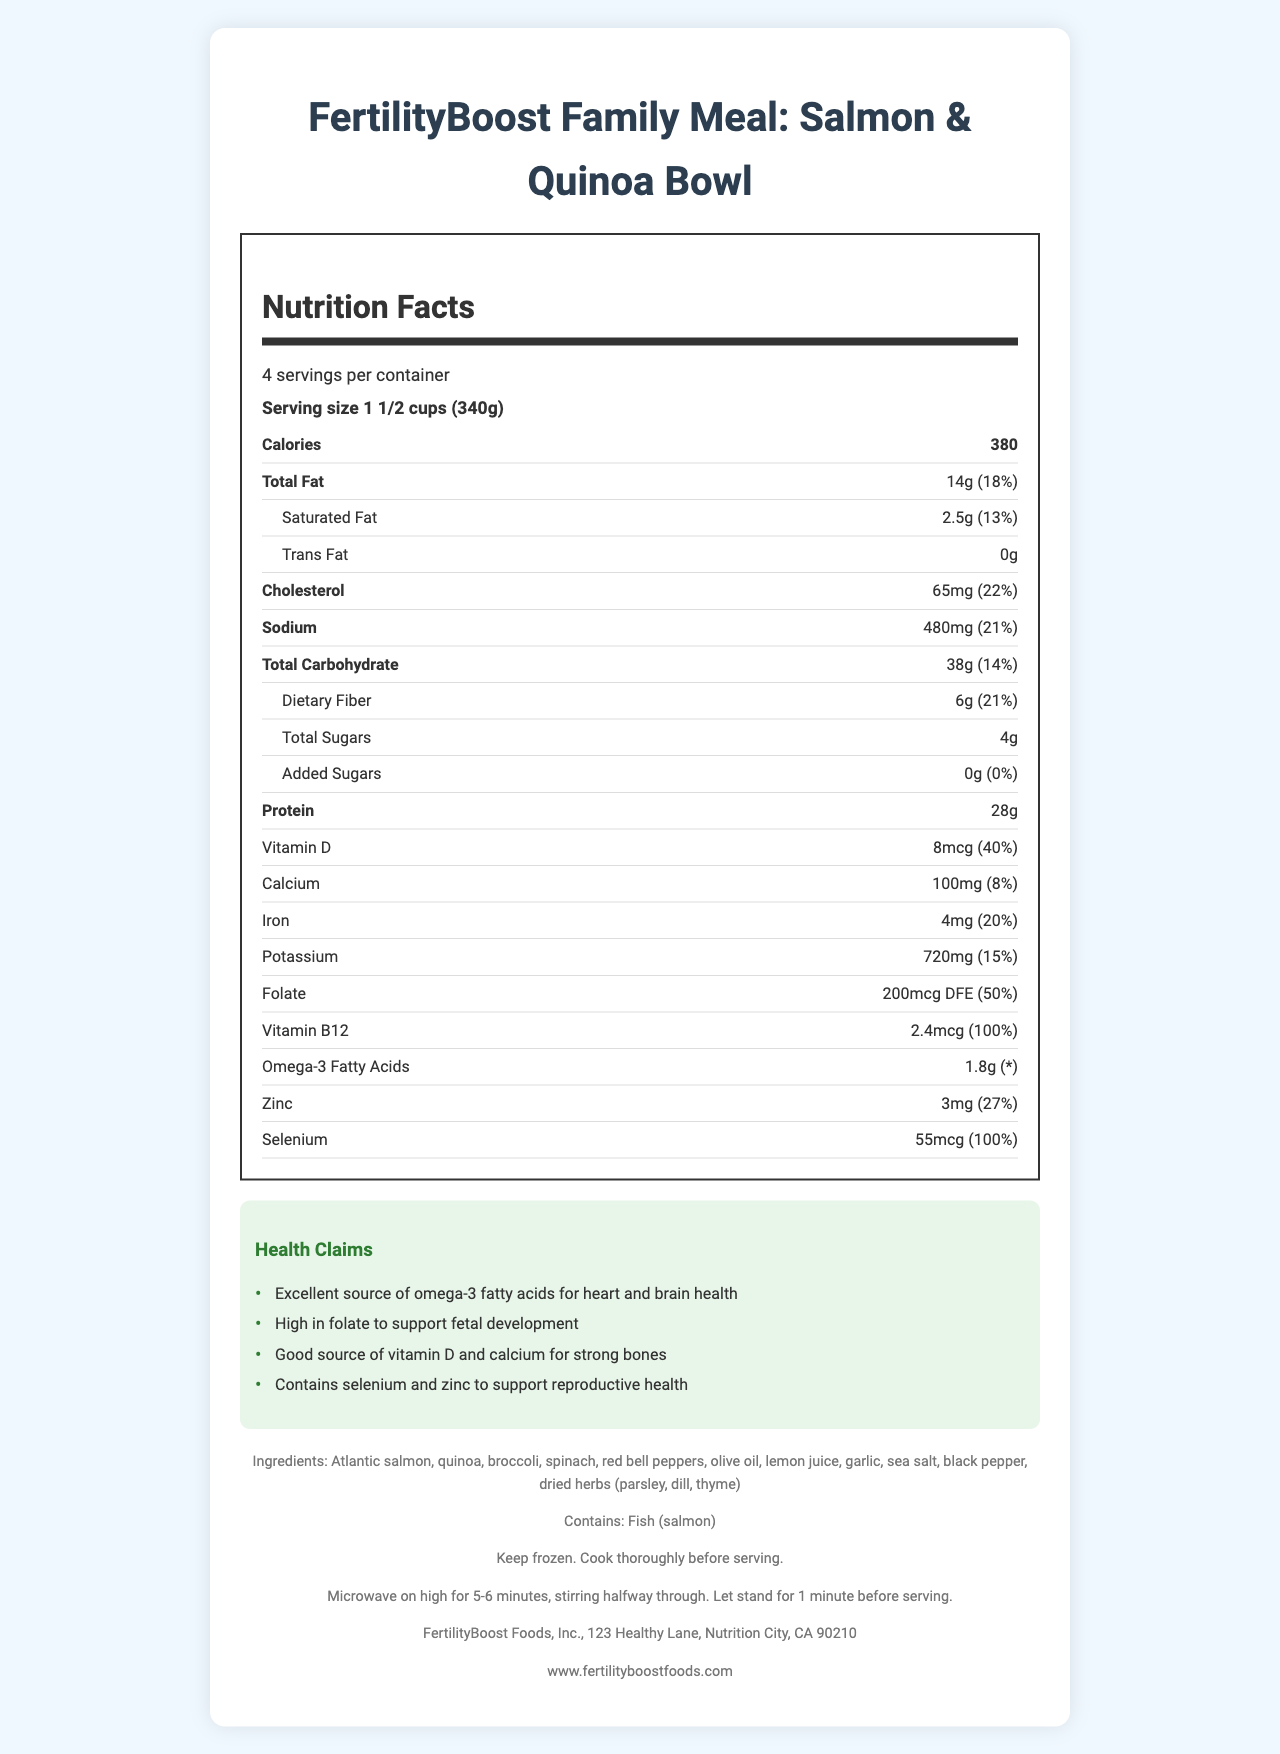What is the serving size of the FertilityBoost Family Meal: Salmon & Quinoa Bowl? The serving size is listed under the "Nutrition Facts" section as "1 1/2 cups (340g)".
Answer: 1 1/2 cups (340g) How many servings per container are there? The document states "4 servings per container".
Answer: 4 How many calories are there per serving? The number of calories per serving is listed as 380.
Answer: 380 What is the amount of protein per serving? The protein amount is listed as 28g per serving.
Answer: 28g What are the two main sources of fat in the meal? The ingredients highlight Atlantic salmon and olive oil as sources of fat.
Answer: Atlantic salmon, olive oil Which nutrient has the highest daily value percentage per serving? A. Zinc B. Vitamin D C. Selenium D. Iron Selenium has a daily value percentage of 100%, which is the highest.
Answer: C How much sodium is in one serving of the meal? A. 480mg B. 720mg C. 100mg D. 65mg The sodium content per serving is listed as 480mg.
Answer: A Does this meal contain any added sugars? The document lists added sugars as 0g.
Answer: No Is this meal high in folate? The daily value percentage for folate is 50%, indicating that the meal is high in folate.
Answer: Yes Does the meal contain any fish allergens? The allergens section lists fish (salmon) as a content.
Answer: Yes Summarize the key points of the document. The document describes a nutrient-rich frozen family meal designed to support reproductive health, highlighting its beneficial ingredients and nutritional content.
Answer: The FertilityBoost Family Meal: Salmon & Quinoa Bowl offers a nutritive meal designed to support reproductive health with high protein, omega-3 fatty acids, vitamins D and B12, folate, zinc, and selenium. It serves 4 with 380 calories per serving and contains beneficial ingredients like salmon, quinoa, and vegetables. Can the preparation instructions be used for cooking the meal in an oven? The document only provides microwave instructions; it does not mention oven preparation methods.
Answer: Not indicated Are there any trans fats in this meal? The document lists trans fats as 0g.
Answer: No Is the meal a good source of calcium? The daily value percentage for calcium is 8%, which is below the threshold to be considered a good source.
Answer: No What are some health benefits of this meal as per the health claims? The health claims section lists these benefits explicitly.
Answer: Supports heart and brain health, supports fetal development, supports strong bones, supports reproductive health 